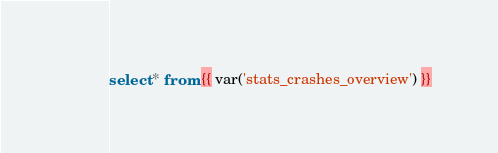<code> <loc_0><loc_0><loc_500><loc_500><_SQL_>select * from {{ var('stats_crashes_overview') }}
</code> 